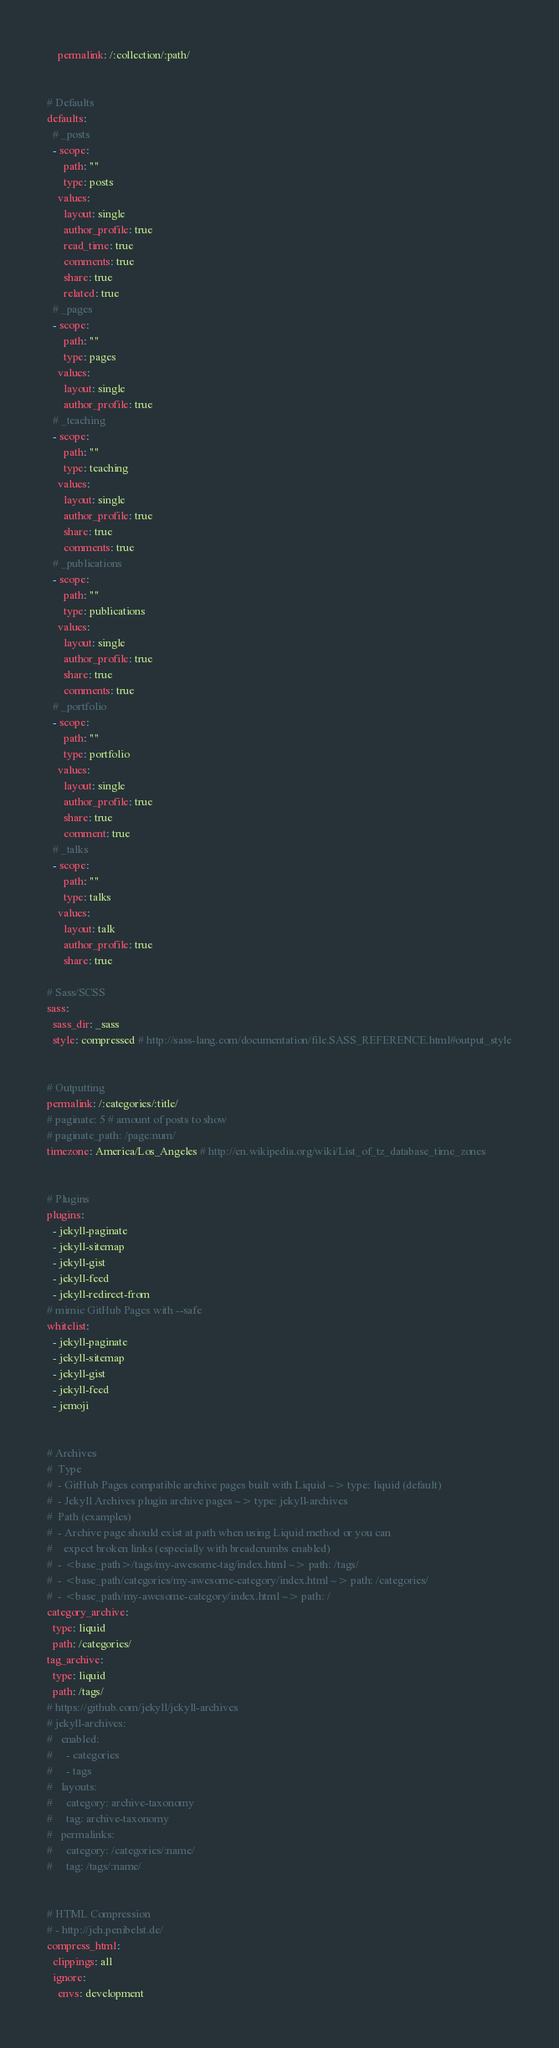Convert code to text. <code><loc_0><loc_0><loc_500><loc_500><_YAML_>    permalink: /:collection/:path/


# Defaults
defaults:
  # _posts
  - scope:
      path: ""
      type: posts
    values:
      layout: single
      author_profile: true
      read_time: true
      comments: true
      share: true
      related: true
  # _pages
  - scope:
      path: ""
      type: pages
    values:
      layout: single
      author_profile: true
  # _teaching
  - scope:
      path: ""
      type: teaching
    values:
      layout: single
      author_profile: true
      share: true
      comments: true
  # _publications
  - scope:
      path: ""
      type: publications
    values:
      layout: single
      author_profile: true
      share: true
      comments: true
  # _portfolio
  - scope:
      path: ""
      type: portfolio
    values:
      layout: single
      author_profile: true
      share: true
      comment: true
  # _talks
  - scope:
      path: ""
      type: talks
    values:
      layout: talk
      author_profile: true
      share: true

# Sass/SCSS
sass:
  sass_dir: _sass
  style: compressed # http://sass-lang.com/documentation/file.SASS_REFERENCE.html#output_style


# Outputting
permalink: /:categories/:title/
# paginate: 5 # amount of posts to show
# paginate_path: /page:num/
timezone: America/Los_Angeles # http://en.wikipedia.org/wiki/List_of_tz_database_time_zones


# Plugins
plugins:
  - jekyll-paginate
  - jekyll-sitemap
  - jekyll-gist
  - jekyll-feed
  - jekyll-redirect-from
# mimic GitHub Pages with --safe
whitelist:
  - jekyll-paginate
  - jekyll-sitemap
  - jekyll-gist
  - jekyll-feed
  - jemoji


# Archives
#  Type
#  - GitHub Pages compatible archive pages built with Liquid ~> type: liquid (default)
#  - Jekyll Archives plugin archive pages ~> type: jekyll-archives
#  Path (examples)
#  - Archive page should exist at path when using Liquid method or you can
#    expect broken links (especially with breadcrumbs enabled)
#  - <base_path>/tags/my-awesome-tag/index.html ~> path: /tags/
#  - <base_path/categories/my-awesome-category/index.html ~> path: /categories/
#  - <base_path/my-awesome-category/index.html ~> path: /
category_archive:
  type: liquid
  path: /categories/
tag_archive:
  type: liquid
  path: /tags/
# https://github.com/jekyll/jekyll-archives
# jekyll-archives:
#   enabled:
#     - categories
#     - tags
#   layouts:
#     category: archive-taxonomy
#     tag: archive-taxonomy
#   permalinks:
#     category: /categories/:name/
#     tag: /tags/:name/


# HTML Compression
# - http://jch.penibelst.de/
compress_html:
  clippings: all
  ignore:
    envs: development
</code> 